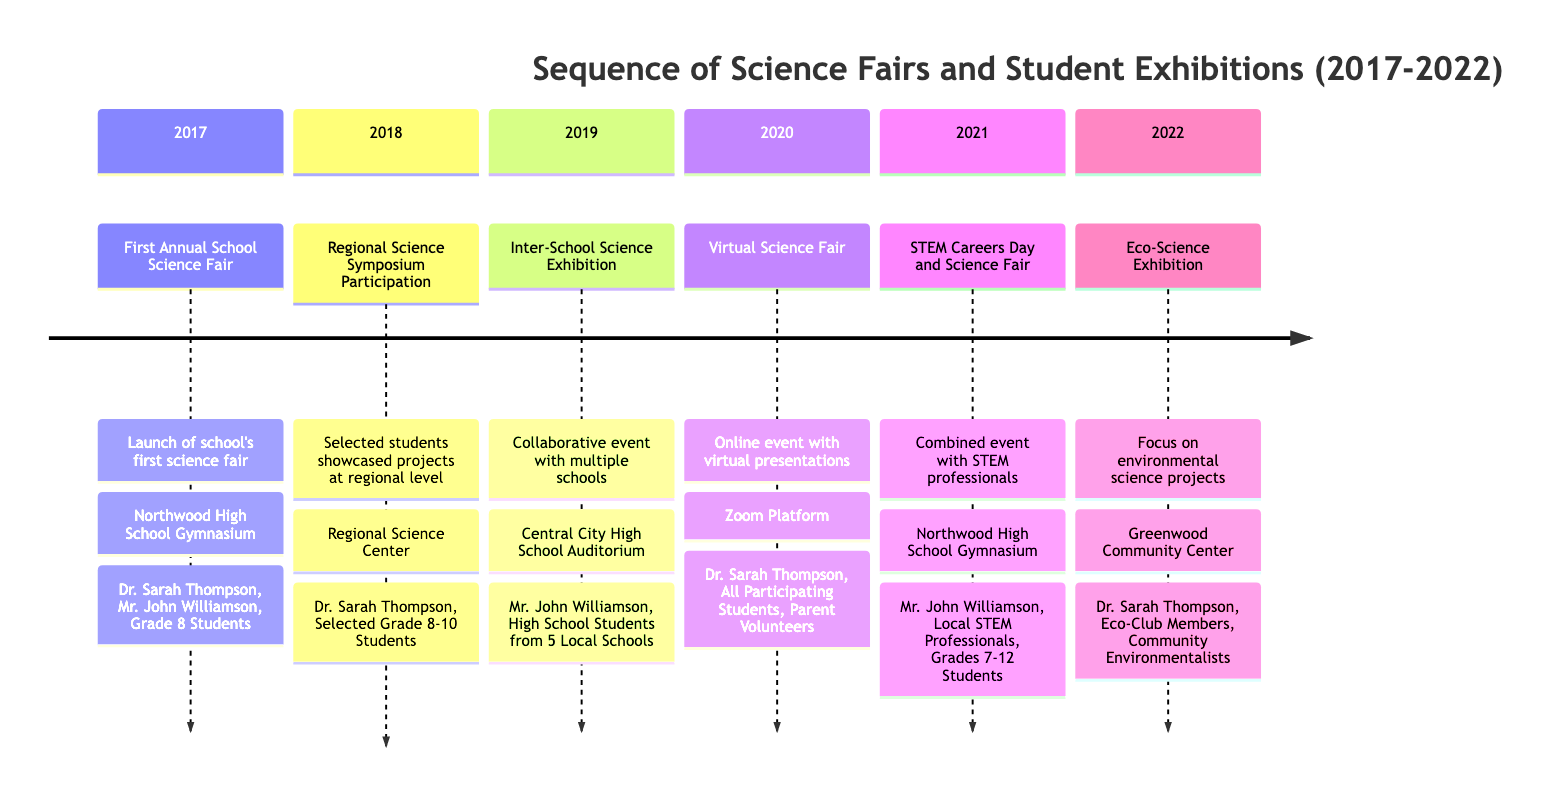What's the first event recorded in the timeline? The timeline starts with the "First Annual School Science Fair" which took place in 2017.
Answer: First Annual School Science Fair How many science fairs were held between 2017 and 2022? The events from 2017 to 2022 include six entries: First Annual School Science Fair, Regional Science Symposium Participation, Inter-School Science Exhibition, Virtual Science Fair, STEM Careers Day and Science Fair, and Eco-Science Exhibition. Counting these gives a total of six events.
Answer: 6 What location hosted the STEM Careers Day and Science Fair event? The diagram specifies that the STEM Careers Day and Science Fair was held at Northwood High School Gymnasium.
Answer: Northwood High School Gymnasium Which key participant was involved in the Virtual Science Fair? By examining the Virtual Science Fair entry, it includes "Dr. Sarah Thompson" as a key participant, alongside all participating students and parent volunteers.
Answer: Dr. Sarah Thompson In what year did the Eco-Science Exhibition occur? The Eco-Science Exhibition is recorded under the year 2022 in the timeline, making it the most recent event related to the science fairs and student exhibitions.
Answer: 2022 Who was a key participant in the Inter-School Science Exhibition? The description for the Inter-School Science Exhibition mentions "Mr. John Williamson" as a key participant, along with high school students from five local schools.
Answer: Mr. John Williamson How did the format of the fair change in 2020? The timeline states that in 2020, the fair adapted to the pandemic by moving to a virtual format. This is shown in the details under the "Virtual Science Fair."
Answer: Online What was the focus of the Eco-Science Exhibition? The entry for the Eco-Science Exhibition explicitly states that it focused on environmental science projects and promoted sustainability awareness.
Answer: Environmental science projects Which event featured participation from grades 7 to 12 students? The "STEM Careers Day and Science Fair" event listed in 2021 specifically included grades 7-12 as participants, indicating broader student engagement across these years.
Answer: STEM Careers Day and Science Fair Which year had a significant shift to virtual engagement for the science fair? The timeline indicates that the "Virtual Science Fair" took place in 2020, highlighting a significant shift due to the pandemic circumstances.
Answer: 2020 